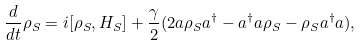Convert formula to latex. <formula><loc_0><loc_0><loc_500><loc_500>\frac { d } { d t } \rho _ { S } = i [ \rho _ { S } , H _ { S } ] + \frac { \gamma } { 2 } ( 2 a \rho _ { S } a ^ { \dag } - a ^ { \dag } a \rho _ { S } - \rho _ { S } a ^ { \dag } a ) ,</formula> 